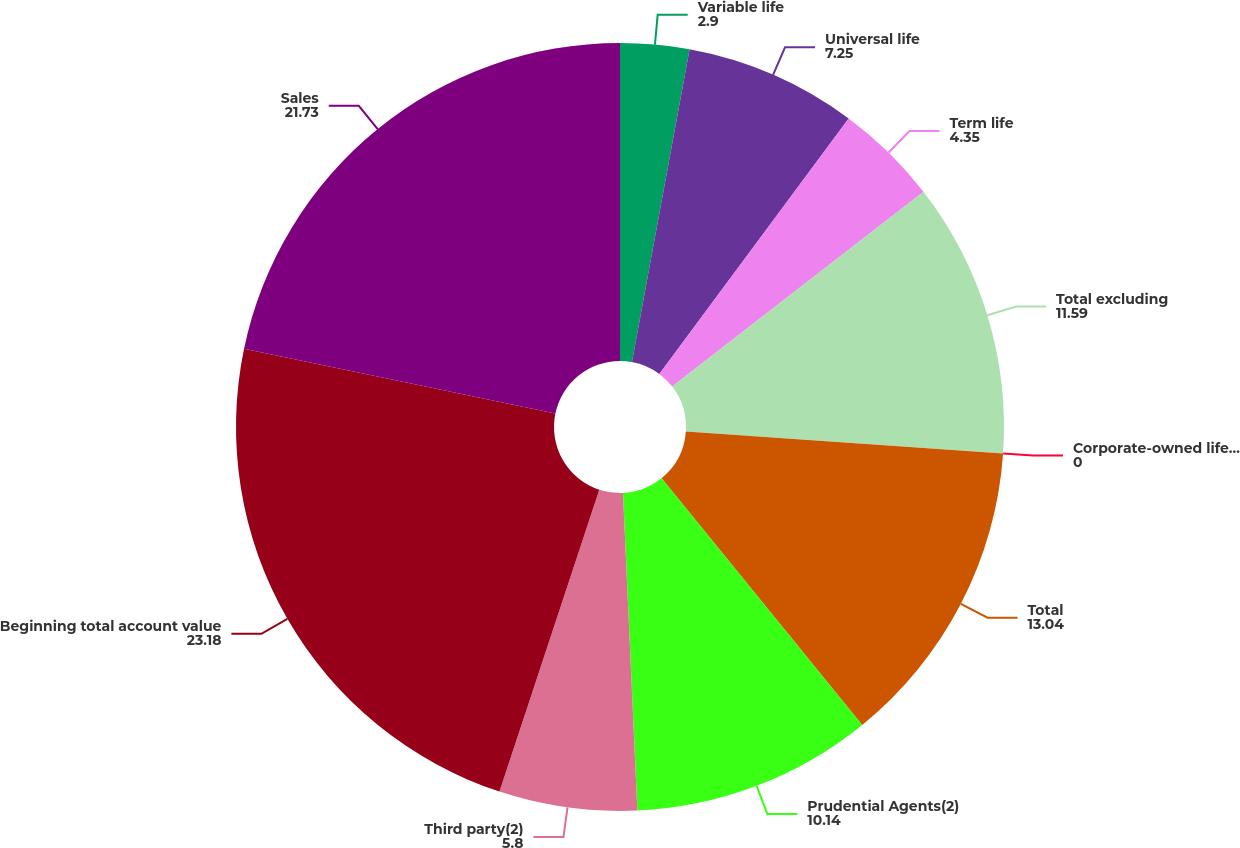Convert chart. <chart><loc_0><loc_0><loc_500><loc_500><pie_chart><fcel>Variable life<fcel>Universal life<fcel>Term life<fcel>Total excluding<fcel>Corporate-owned life insurance<fcel>Total<fcel>Prudential Agents(2)<fcel>Third party(2)<fcel>Beginning total account value<fcel>Sales<nl><fcel>2.9%<fcel>7.25%<fcel>4.35%<fcel>11.59%<fcel>0.0%<fcel>13.04%<fcel>10.14%<fcel>5.8%<fcel>23.18%<fcel>21.73%<nl></chart> 